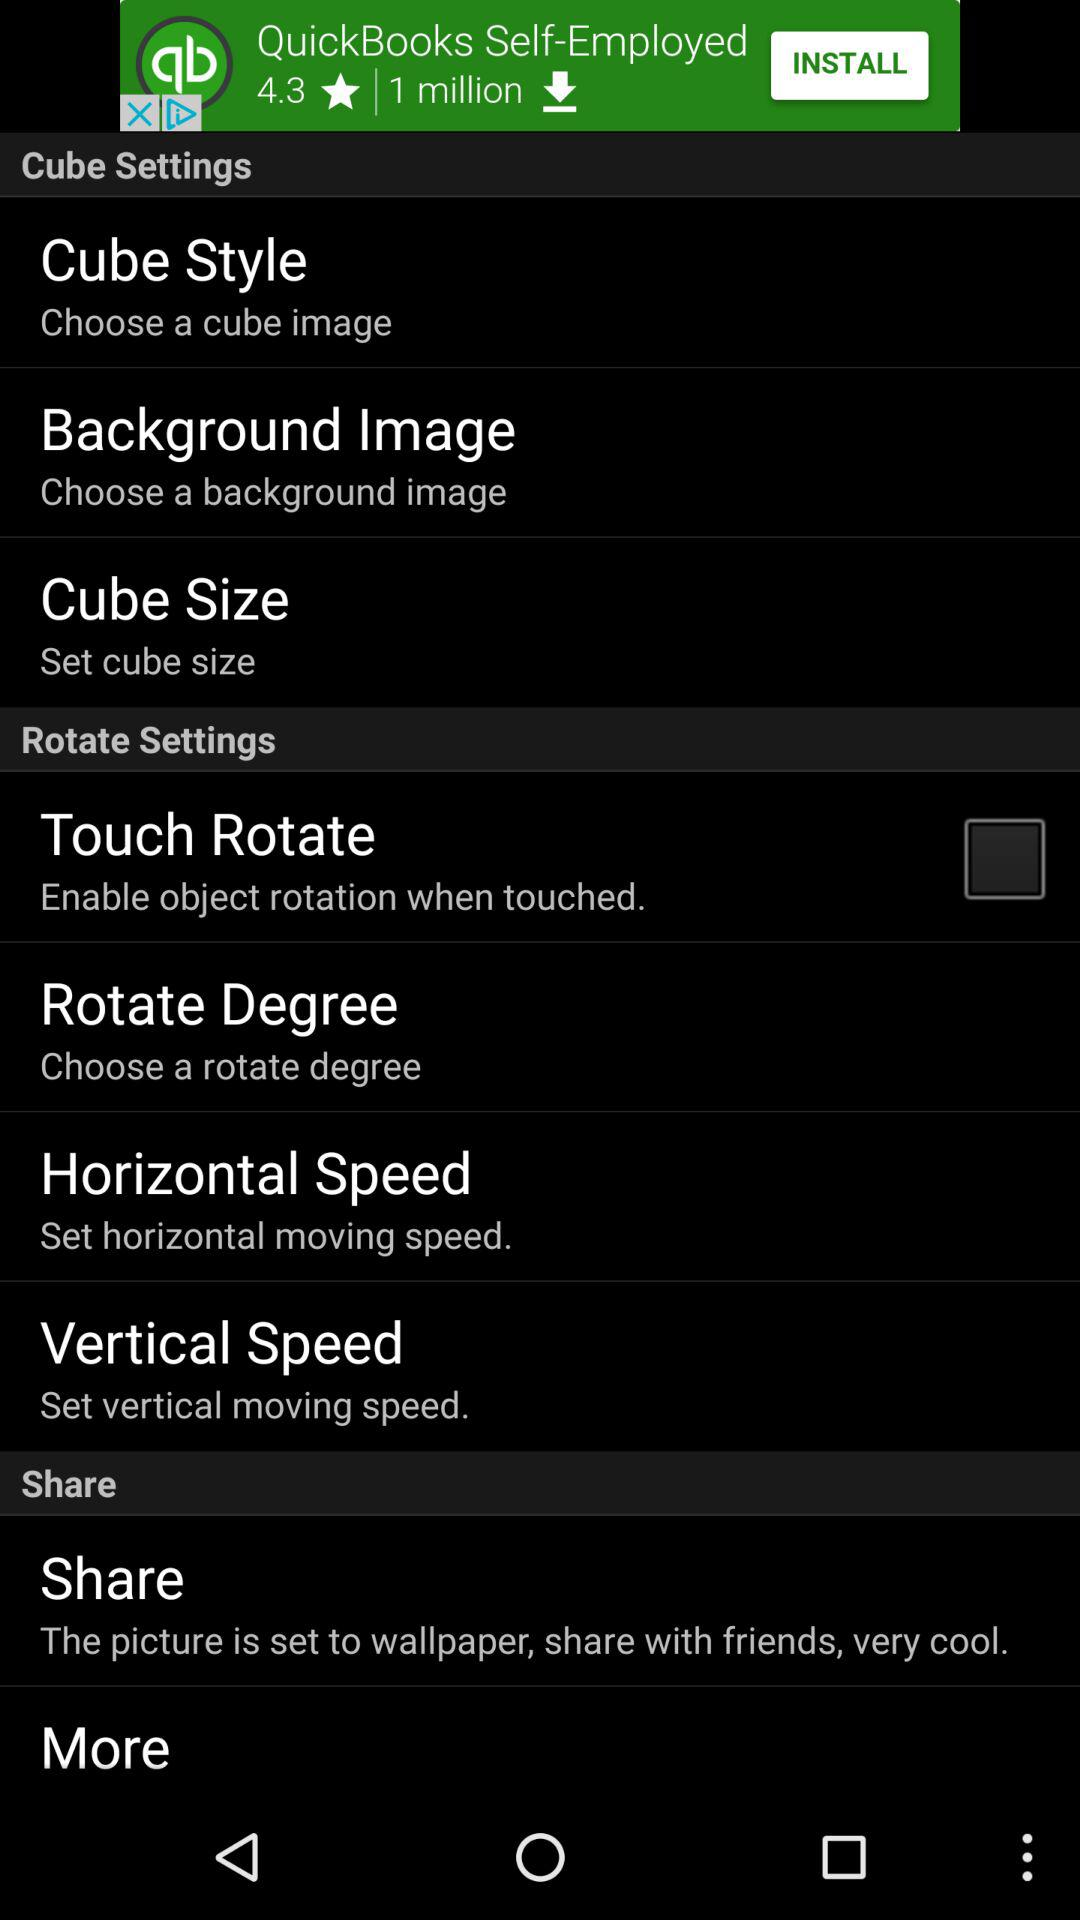How many rotate settings are there?
Answer the question using a single word or phrase. 4 